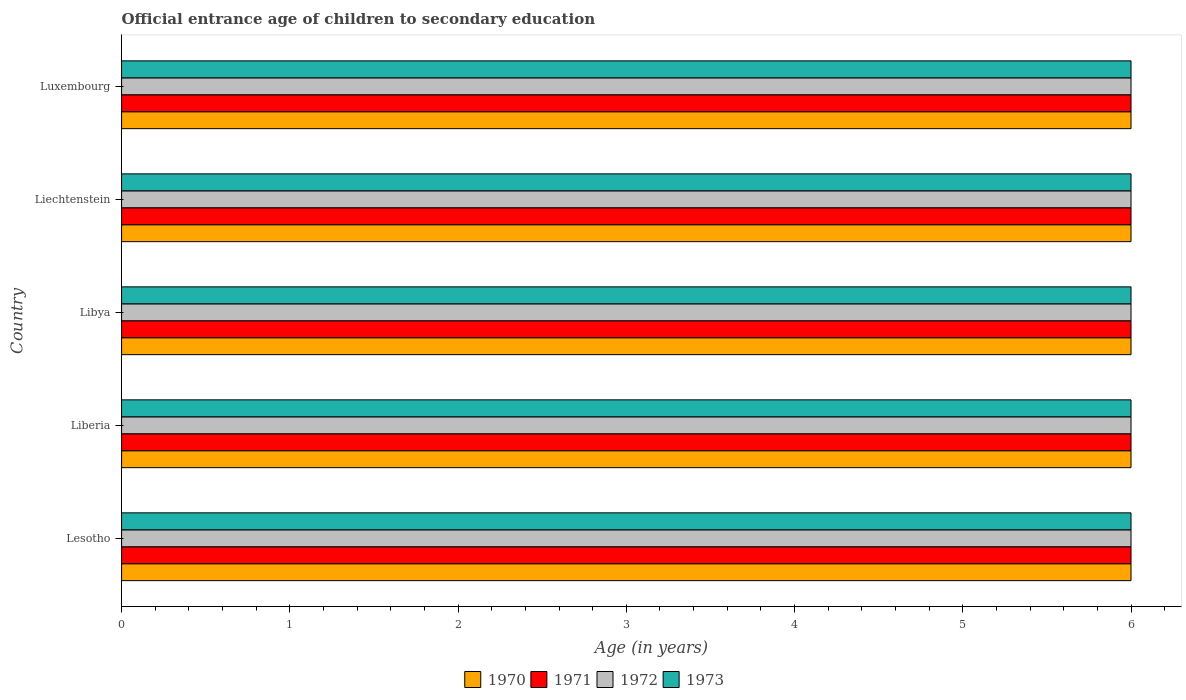How many bars are there on the 3rd tick from the top?
Ensure brevity in your answer.  4. How many bars are there on the 5th tick from the bottom?
Offer a very short reply. 4. What is the label of the 2nd group of bars from the top?
Offer a very short reply. Liechtenstein. In how many cases, is the number of bars for a given country not equal to the number of legend labels?
Keep it short and to the point. 0. In which country was the secondary school starting age of children in 1970 maximum?
Provide a short and direct response. Lesotho. In which country was the secondary school starting age of children in 1973 minimum?
Offer a very short reply. Lesotho. In how many countries, is the secondary school starting age of children in 1970 greater than 1.6 years?
Provide a short and direct response. 5. What is the ratio of the secondary school starting age of children in 1971 in Liberia to that in Luxembourg?
Provide a short and direct response. 1. Is the secondary school starting age of children in 1971 in Lesotho less than that in Liechtenstein?
Offer a terse response. No. Is the difference between the secondary school starting age of children in 1971 in Libya and Liechtenstein greater than the difference between the secondary school starting age of children in 1973 in Libya and Liechtenstein?
Your answer should be compact. No. What is the difference between the highest and the lowest secondary school starting age of children in 1973?
Provide a succinct answer. 0. What does the 4th bar from the bottom in Luxembourg represents?
Make the answer very short. 1973. Is it the case that in every country, the sum of the secondary school starting age of children in 1971 and secondary school starting age of children in 1972 is greater than the secondary school starting age of children in 1973?
Your answer should be compact. Yes. How many bars are there?
Provide a short and direct response. 20. Are all the bars in the graph horizontal?
Your answer should be very brief. Yes. How many countries are there in the graph?
Offer a terse response. 5. Does the graph contain any zero values?
Ensure brevity in your answer.  No. How many legend labels are there?
Provide a short and direct response. 4. How are the legend labels stacked?
Your answer should be compact. Horizontal. What is the title of the graph?
Provide a succinct answer. Official entrance age of children to secondary education. Does "1993" appear as one of the legend labels in the graph?
Provide a succinct answer. No. What is the label or title of the X-axis?
Keep it short and to the point. Age (in years). What is the Age (in years) in 1970 in Liberia?
Your answer should be compact. 6. What is the Age (in years) of 1971 in Liberia?
Your answer should be compact. 6. What is the Age (in years) of 1972 in Liberia?
Your response must be concise. 6. What is the Age (in years) in 1973 in Liberia?
Make the answer very short. 6. What is the Age (in years) in 1970 in Libya?
Give a very brief answer. 6. What is the Age (in years) of 1971 in Libya?
Provide a short and direct response. 6. What is the Age (in years) in 1972 in Libya?
Ensure brevity in your answer.  6. What is the Age (in years) in 1970 in Liechtenstein?
Keep it short and to the point. 6. What is the Age (in years) of 1972 in Luxembourg?
Give a very brief answer. 6. What is the Age (in years) of 1973 in Luxembourg?
Provide a succinct answer. 6. Across all countries, what is the maximum Age (in years) of 1970?
Your answer should be compact. 6. Across all countries, what is the minimum Age (in years) in 1971?
Your answer should be very brief. 6. What is the total Age (in years) in 1973 in the graph?
Make the answer very short. 30. What is the difference between the Age (in years) in 1970 in Lesotho and that in Liberia?
Offer a very short reply. 0. What is the difference between the Age (in years) of 1971 in Lesotho and that in Liberia?
Make the answer very short. 0. What is the difference between the Age (in years) in 1971 in Lesotho and that in Libya?
Provide a succinct answer. 0. What is the difference between the Age (in years) of 1970 in Lesotho and that in Liechtenstein?
Your answer should be very brief. 0. What is the difference between the Age (in years) in 1970 in Lesotho and that in Luxembourg?
Provide a short and direct response. 0. What is the difference between the Age (in years) in 1971 in Lesotho and that in Luxembourg?
Your answer should be compact. 0. What is the difference between the Age (in years) in 1972 in Lesotho and that in Luxembourg?
Ensure brevity in your answer.  0. What is the difference between the Age (in years) of 1971 in Liberia and that in Liechtenstein?
Your answer should be compact. 0. What is the difference between the Age (in years) in 1970 in Liberia and that in Luxembourg?
Offer a terse response. 0. What is the difference between the Age (in years) in 1972 in Liberia and that in Luxembourg?
Provide a succinct answer. 0. What is the difference between the Age (in years) of 1970 in Libya and that in Liechtenstein?
Your response must be concise. 0. What is the difference between the Age (in years) of 1971 in Libya and that in Liechtenstein?
Provide a short and direct response. 0. What is the difference between the Age (in years) in 1973 in Libya and that in Liechtenstein?
Offer a terse response. 0. What is the difference between the Age (in years) of 1970 in Libya and that in Luxembourg?
Your answer should be very brief. 0. What is the difference between the Age (in years) of 1972 in Libya and that in Luxembourg?
Offer a very short reply. 0. What is the difference between the Age (in years) in 1970 in Lesotho and the Age (in years) in 1971 in Liberia?
Your answer should be compact. 0. What is the difference between the Age (in years) of 1970 in Lesotho and the Age (in years) of 1972 in Liberia?
Make the answer very short. 0. What is the difference between the Age (in years) of 1970 in Lesotho and the Age (in years) of 1973 in Libya?
Provide a short and direct response. 0. What is the difference between the Age (in years) of 1971 in Lesotho and the Age (in years) of 1973 in Libya?
Your answer should be compact. 0. What is the difference between the Age (in years) of 1970 in Lesotho and the Age (in years) of 1972 in Liechtenstein?
Ensure brevity in your answer.  0. What is the difference between the Age (in years) in 1970 in Lesotho and the Age (in years) in 1973 in Liechtenstein?
Your answer should be very brief. 0. What is the difference between the Age (in years) of 1971 in Lesotho and the Age (in years) of 1972 in Liechtenstein?
Offer a very short reply. 0. What is the difference between the Age (in years) in 1971 in Lesotho and the Age (in years) in 1973 in Liechtenstein?
Offer a terse response. 0. What is the difference between the Age (in years) of 1972 in Lesotho and the Age (in years) of 1973 in Liechtenstein?
Your answer should be compact. 0. What is the difference between the Age (in years) in 1970 in Lesotho and the Age (in years) in 1971 in Luxembourg?
Make the answer very short. 0. What is the difference between the Age (in years) of 1970 in Lesotho and the Age (in years) of 1972 in Luxembourg?
Provide a short and direct response. 0. What is the difference between the Age (in years) of 1971 in Lesotho and the Age (in years) of 1972 in Luxembourg?
Offer a very short reply. 0. What is the difference between the Age (in years) of 1970 in Liberia and the Age (in years) of 1972 in Liechtenstein?
Offer a very short reply. 0. What is the difference between the Age (in years) in 1971 in Liberia and the Age (in years) in 1972 in Liechtenstein?
Offer a very short reply. 0. What is the difference between the Age (in years) of 1971 in Liberia and the Age (in years) of 1973 in Liechtenstein?
Your answer should be compact. 0. What is the difference between the Age (in years) of 1972 in Liberia and the Age (in years) of 1973 in Liechtenstein?
Give a very brief answer. 0. What is the difference between the Age (in years) of 1970 in Liberia and the Age (in years) of 1972 in Luxembourg?
Keep it short and to the point. 0. What is the difference between the Age (in years) of 1970 in Liberia and the Age (in years) of 1973 in Luxembourg?
Your answer should be compact. 0. What is the difference between the Age (in years) of 1971 in Liberia and the Age (in years) of 1973 in Luxembourg?
Provide a succinct answer. 0. What is the difference between the Age (in years) in 1970 in Libya and the Age (in years) in 1971 in Liechtenstein?
Ensure brevity in your answer.  0. What is the difference between the Age (in years) in 1970 in Libya and the Age (in years) in 1973 in Liechtenstein?
Give a very brief answer. 0. What is the difference between the Age (in years) in 1971 in Libya and the Age (in years) in 1972 in Liechtenstein?
Your answer should be very brief. 0. What is the difference between the Age (in years) of 1970 in Libya and the Age (in years) of 1971 in Luxembourg?
Make the answer very short. 0. What is the difference between the Age (in years) of 1970 in Libya and the Age (in years) of 1973 in Luxembourg?
Your response must be concise. 0. What is the difference between the Age (in years) of 1971 in Libya and the Age (in years) of 1972 in Luxembourg?
Your answer should be compact. 0. What is the difference between the Age (in years) of 1971 in Libya and the Age (in years) of 1973 in Luxembourg?
Ensure brevity in your answer.  0. What is the average Age (in years) in 1970 per country?
Provide a succinct answer. 6. What is the average Age (in years) of 1973 per country?
Your response must be concise. 6. What is the difference between the Age (in years) of 1970 and Age (in years) of 1971 in Lesotho?
Keep it short and to the point. 0. What is the difference between the Age (in years) of 1970 and Age (in years) of 1972 in Lesotho?
Keep it short and to the point. 0. What is the difference between the Age (in years) of 1972 and Age (in years) of 1973 in Lesotho?
Your answer should be very brief. 0. What is the difference between the Age (in years) in 1970 and Age (in years) in 1971 in Liberia?
Your answer should be very brief. 0. What is the difference between the Age (in years) of 1970 and Age (in years) of 1972 in Liberia?
Give a very brief answer. 0. What is the difference between the Age (in years) in 1971 and Age (in years) in 1972 in Liberia?
Ensure brevity in your answer.  0. What is the difference between the Age (in years) in 1971 and Age (in years) in 1973 in Liberia?
Your response must be concise. 0. What is the difference between the Age (in years) in 1972 and Age (in years) in 1973 in Liberia?
Offer a terse response. 0. What is the difference between the Age (in years) of 1970 and Age (in years) of 1971 in Libya?
Ensure brevity in your answer.  0. What is the difference between the Age (in years) in 1970 and Age (in years) in 1972 in Libya?
Your response must be concise. 0. What is the difference between the Age (in years) of 1971 and Age (in years) of 1972 in Libya?
Your response must be concise. 0. What is the difference between the Age (in years) of 1971 and Age (in years) of 1973 in Libya?
Your answer should be compact. 0. What is the difference between the Age (in years) of 1970 and Age (in years) of 1973 in Liechtenstein?
Offer a terse response. 0. What is the difference between the Age (in years) of 1972 and Age (in years) of 1973 in Liechtenstein?
Provide a short and direct response. 0. What is the difference between the Age (in years) of 1970 and Age (in years) of 1973 in Luxembourg?
Keep it short and to the point. 0. What is the difference between the Age (in years) of 1971 and Age (in years) of 1973 in Luxembourg?
Provide a short and direct response. 0. What is the ratio of the Age (in years) of 1970 in Lesotho to that in Liberia?
Provide a succinct answer. 1. What is the ratio of the Age (in years) in 1972 in Lesotho to that in Libya?
Provide a succinct answer. 1. What is the ratio of the Age (in years) in 1973 in Lesotho to that in Libya?
Your answer should be very brief. 1. What is the ratio of the Age (in years) of 1973 in Lesotho to that in Liechtenstein?
Make the answer very short. 1. What is the ratio of the Age (in years) in 1970 in Liberia to that in Libya?
Make the answer very short. 1. What is the ratio of the Age (in years) of 1971 in Liberia to that in Libya?
Offer a terse response. 1. What is the ratio of the Age (in years) of 1970 in Liberia to that in Liechtenstein?
Ensure brevity in your answer.  1. What is the ratio of the Age (in years) of 1973 in Liberia to that in Liechtenstein?
Provide a short and direct response. 1. What is the ratio of the Age (in years) in 1970 in Liberia to that in Luxembourg?
Your answer should be compact. 1. What is the ratio of the Age (in years) of 1971 in Liberia to that in Luxembourg?
Your response must be concise. 1. What is the ratio of the Age (in years) in 1972 in Liberia to that in Luxembourg?
Your response must be concise. 1. What is the ratio of the Age (in years) in 1971 in Libya to that in Liechtenstein?
Make the answer very short. 1. What is the ratio of the Age (in years) in 1972 in Libya to that in Luxembourg?
Offer a terse response. 1. What is the ratio of the Age (in years) of 1970 in Liechtenstein to that in Luxembourg?
Offer a very short reply. 1. What is the difference between the highest and the second highest Age (in years) of 1970?
Offer a very short reply. 0. What is the difference between the highest and the second highest Age (in years) of 1971?
Keep it short and to the point. 0. What is the difference between the highest and the lowest Age (in years) in 1971?
Your answer should be compact. 0. What is the difference between the highest and the lowest Age (in years) of 1972?
Ensure brevity in your answer.  0. What is the difference between the highest and the lowest Age (in years) of 1973?
Make the answer very short. 0. 